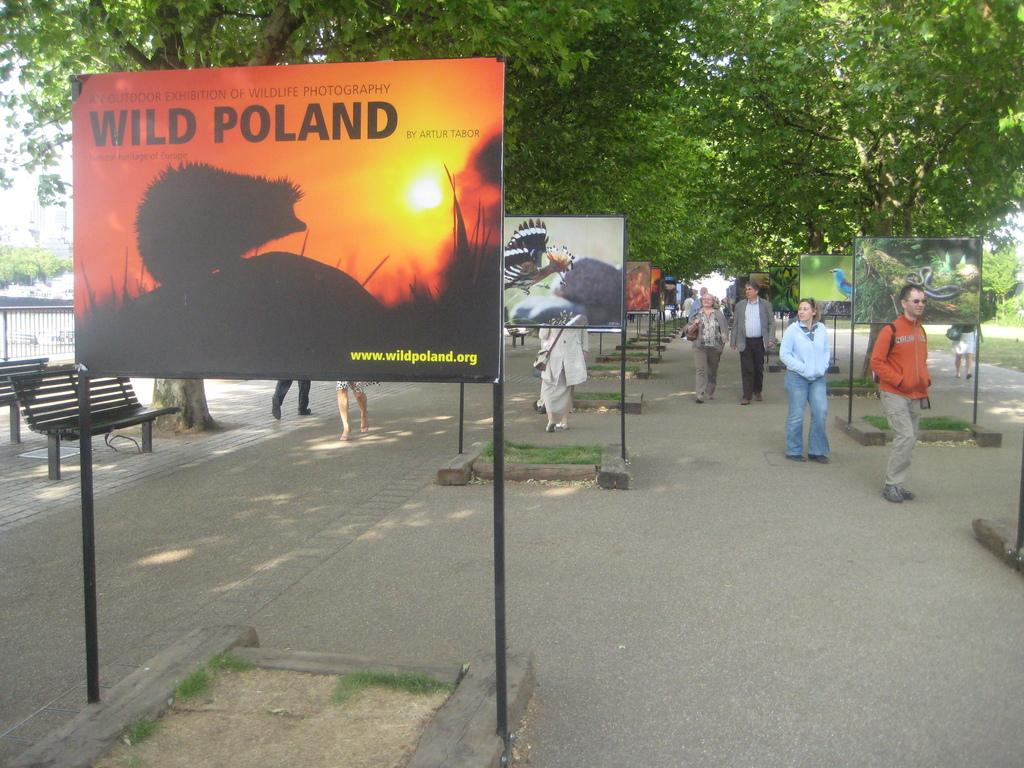Provide a one-sentence caption for the provided image. A few people walk down a sidewalk where a sign promotes a photography exhibition. 